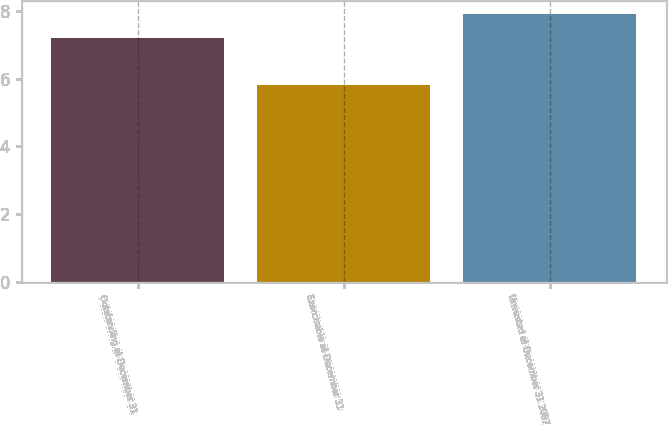<chart> <loc_0><loc_0><loc_500><loc_500><bar_chart><fcel>Outstanding at December 31<fcel>Exercisable at December 31<fcel>Unvested at December 31 2007<nl><fcel>7.2<fcel>5.8<fcel>7.9<nl></chart> 